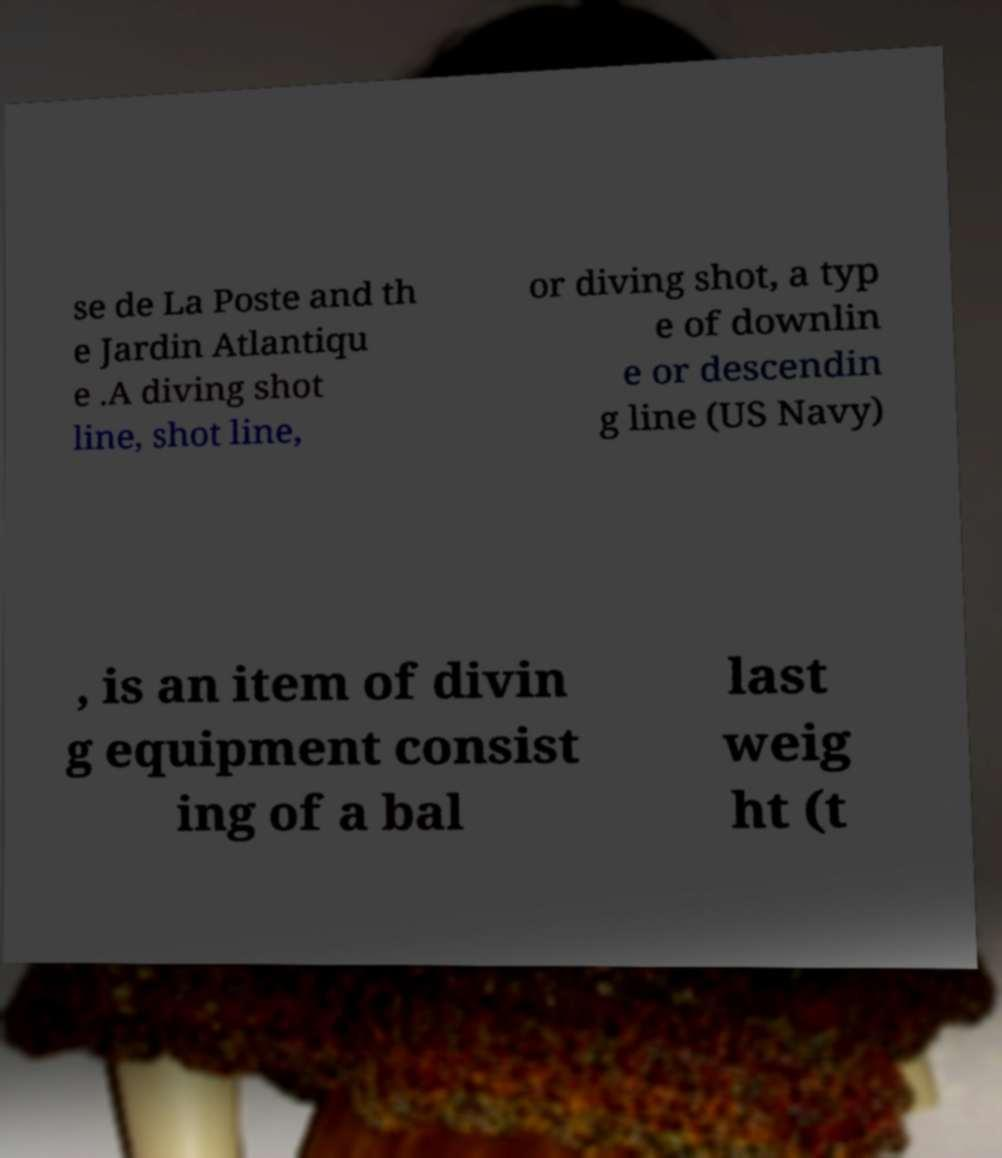For documentation purposes, I need the text within this image transcribed. Could you provide that? se de La Poste and th e Jardin Atlantiqu e .A diving shot line, shot line, or diving shot, a typ e of downlin e or descendin g line (US Navy) , is an item of divin g equipment consist ing of a bal last weig ht (t 